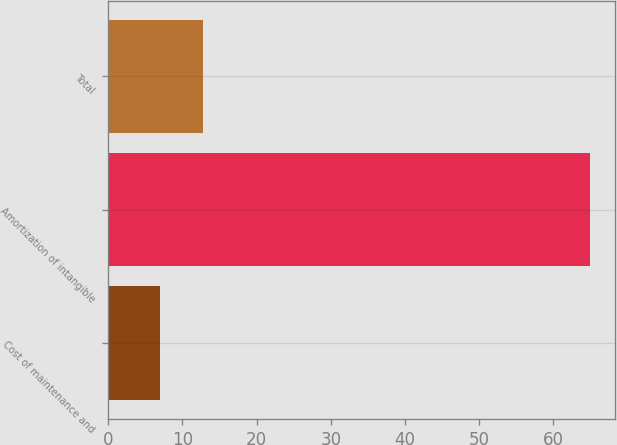Convert chart. <chart><loc_0><loc_0><loc_500><loc_500><bar_chart><fcel>Cost of maintenance and<fcel>Amortization of intangible<fcel>Total<nl><fcel>7<fcel>65<fcel>12.8<nl></chart> 